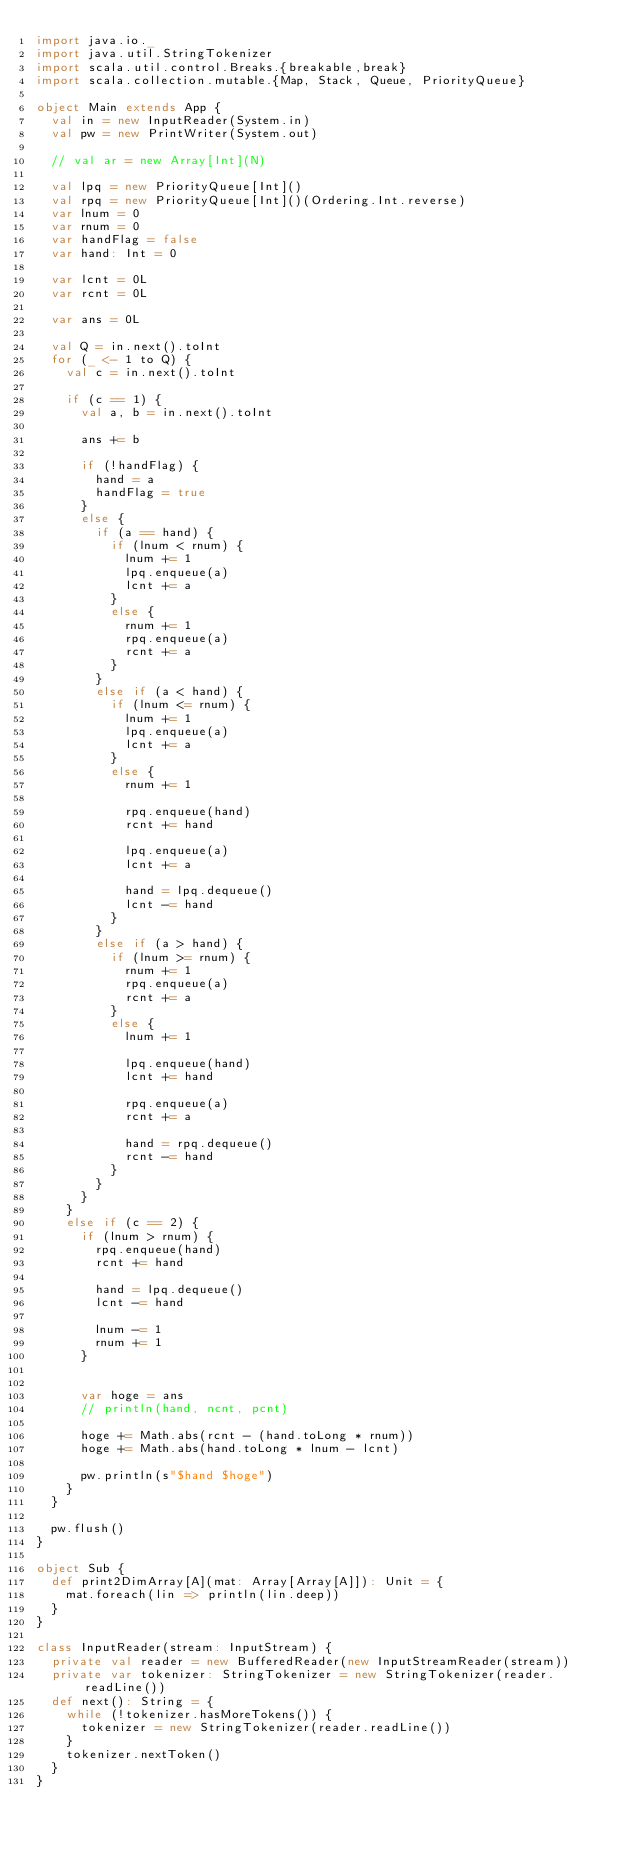<code> <loc_0><loc_0><loc_500><loc_500><_Scala_>import java.io._
import java.util.StringTokenizer
import scala.util.control.Breaks.{breakable,break}
import scala.collection.mutable.{Map, Stack, Queue, PriorityQueue}

object Main extends App {
  val in = new InputReader(System.in)
  val pw = new PrintWriter(System.out)

  // val ar = new Array[Int](N)

  val lpq = new PriorityQueue[Int]()
  val rpq = new PriorityQueue[Int]()(Ordering.Int.reverse)
  var lnum = 0
  var rnum = 0
  var handFlag = false
  var hand: Int = 0

  var lcnt = 0L
  var rcnt = 0L

  var ans = 0L

  val Q = in.next().toInt
  for (_ <- 1 to Q) {
    val c = in.next().toInt

    if (c == 1) {
      val a, b = in.next().toInt

      ans += b

      if (!handFlag) {
        hand = a
        handFlag = true
      }
      else {
        if (a == hand) {
          if (lnum < rnum) {
            lnum += 1
            lpq.enqueue(a)
            lcnt += a
          }
          else {
            rnum += 1
            rpq.enqueue(a)
            rcnt += a
          }
        }
        else if (a < hand) {
          if (lnum <= rnum) {
            lnum += 1
            lpq.enqueue(a)
            lcnt += a
          }
          else {
            rnum += 1

            rpq.enqueue(hand)
            rcnt += hand

            lpq.enqueue(a)
            lcnt += a

            hand = lpq.dequeue()
            lcnt -= hand
          }
        }
        else if (a > hand) {
          if (lnum >= rnum) {
            rnum += 1
            rpq.enqueue(a)
            rcnt += a
          }
          else {
            lnum += 1

            lpq.enqueue(hand)
            lcnt += hand

            rpq.enqueue(a)
            rcnt += a

            hand = rpq.dequeue()
            rcnt -= hand
          }
        }
      }
    }
    else if (c == 2) {
      if (lnum > rnum) {
        rpq.enqueue(hand)
        rcnt += hand

        hand = lpq.dequeue()
        lcnt -= hand

        lnum -= 1
        rnum += 1
      }


      var hoge = ans
      // println(hand, ncnt, pcnt)

      hoge += Math.abs(rcnt - (hand.toLong * rnum))
      hoge += Math.abs(hand.toLong * lnum - lcnt)
      
      pw.println(s"$hand $hoge")
    }
  }

  pw.flush()
}

object Sub {
  def print2DimArray[A](mat: Array[Array[A]]): Unit = {
    mat.foreach(lin => println(lin.deep))
  }
}

class InputReader(stream: InputStream) {
  private val reader = new BufferedReader(new InputStreamReader(stream))
  private var tokenizer: StringTokenizer = new StringTokenizer(reader.readLine())
  def next(): String = {
    while (!tokenizer.hasMoreTokens()) {
      tokenizer = new StringTokenizer(reader.readLine())
    }
    tokenizer.nextToken()
  }
}
</code> 